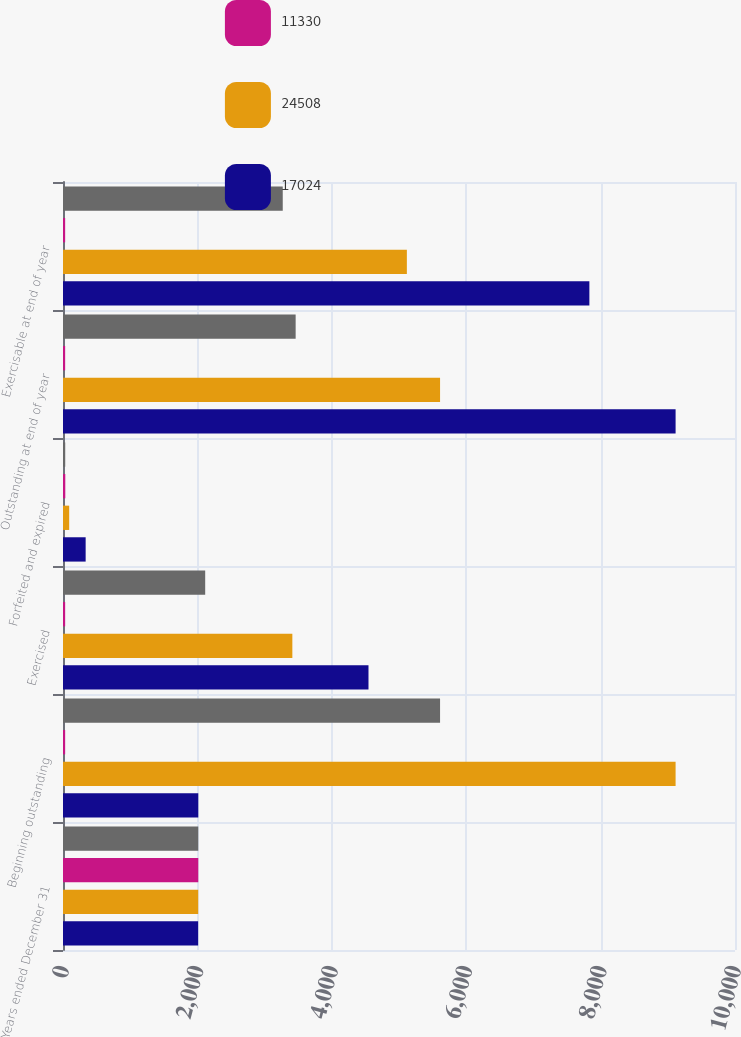Convert chart. <chart><loc_0><loc_0><loc_500><loc_500><stacked_bar_chart><ecel><fcel>Years ended December 31<fcel>Beginning outstanding<fcel>Exercised<fcel>Forfeited and expired<fcel>Outstanding at end of year<fcel>Exercisable at end of year<nl><fcel>nan<fcel>2013<fcel>5611<fcel>2116<fcel>33<fcel>3462<fcel>3270<nl><fcel>11330<fcel>2013<fcel>32<fcel>32<fcel>34<fcel>32<fcel>32<nl><fcel>24508<fcel>2012<fcel>9116<fcel>3413<fcel>92<fcel>5611<fcel>5117<nl><fcel>17024<fcel>2011<fcel>2013<fcel>4546<fcel>337<fcel>9116<fcel>7833<nl></chart> 